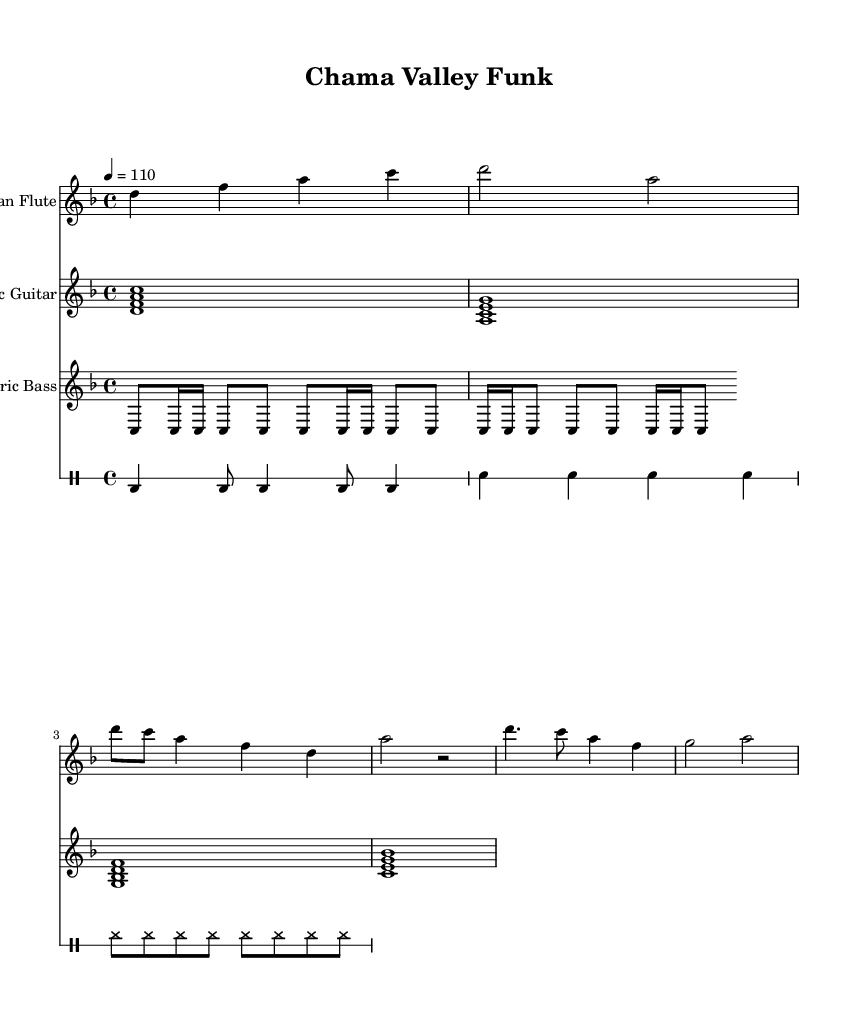What is the key signature of this music? The key signature is indicated at the beginning of the score. It shows that there are two flat notes, which corresponds to the key of D minor.
Answer: D minor What is the time signature of this music? The time signature is noted at the start of the score and is shown as 4/4, meaning there are four beats in each measure and a quarter note receives one beat.
Answer: 4/4 What is the tempo marking for this piece? The tempo marking is given in the score, where it states a metronome marking of 110, indicating how fast the piece should be played.
Answer: 110 How many instruments are featured in this score? By counting the staves in the score, we see there are four distinct instrumental parts: Native American Flute, Electric Guitar, Electric Bass, and Drums.
Answer: Four What type of groove does the electric bass part use? The electric bass part employs a repeated rhythmic pattern, which consists of eighth and sixteenth notes, characteristic of funk music to create a driving groove.
Answer: Funk groove What does the drum pattern predominantly feature? The drum pattern is characterized primarily by the bass drum and snare hits, with consistent hi-hat rhythms, common in funk to maintain the beat.
Answer: Bass and snare What melodic interval is primarily used in the Native American flute part for the intro? The melodic interval in the intro section mainly revolves around the interval of a fourth, specifically moving from D to A, which is a perfect fourth.
Answer: Perfect fourth 